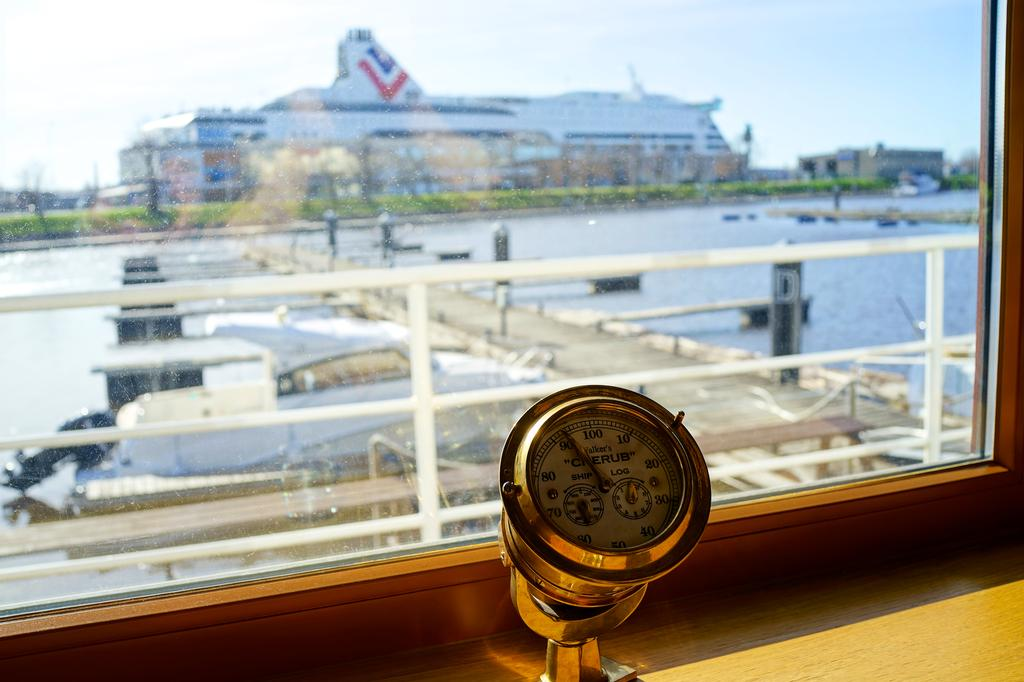<image>
Offer a succinct explanation of the picture presented. a ship gauge reads Walker's Cherub Ship Log and looks over a harbor 